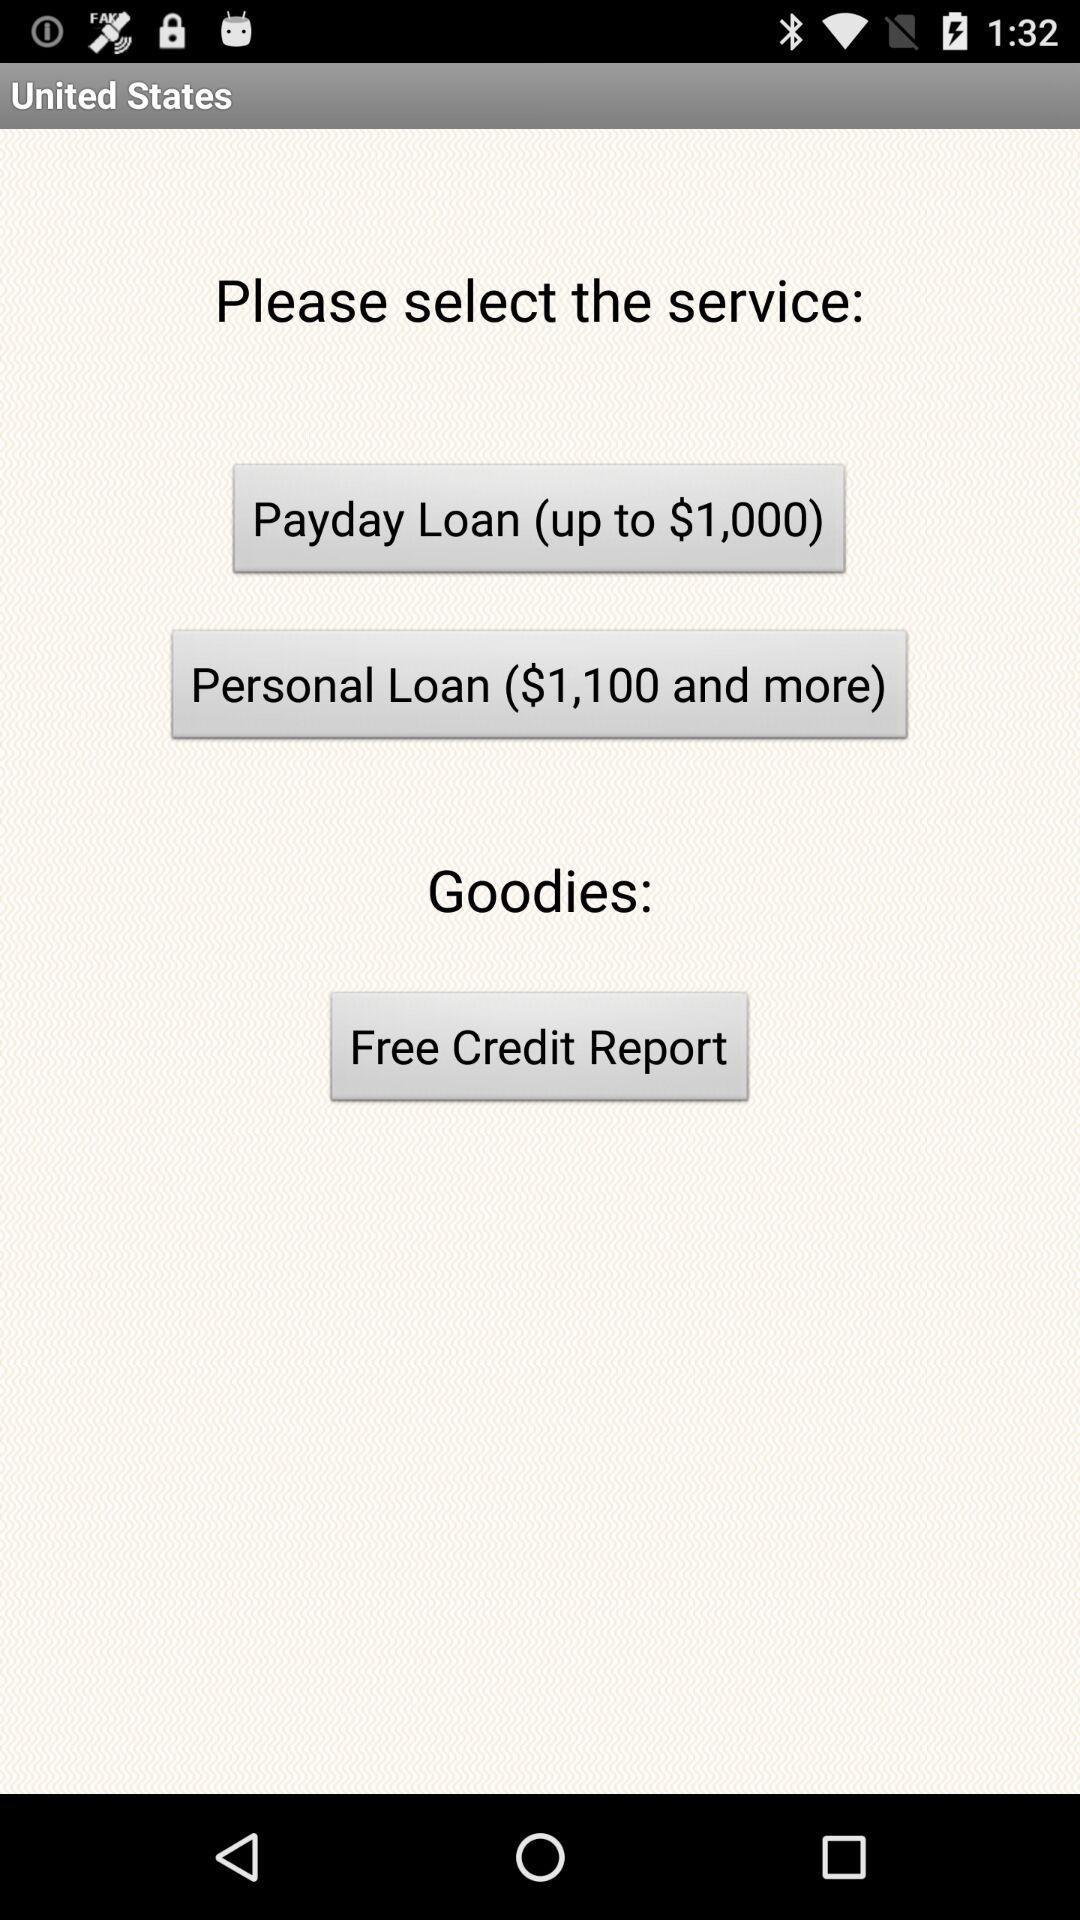What are the different available services? The different available services are "Payday Loan (up to $1,000)" and "Personal Loan ($1,100 and more)". 